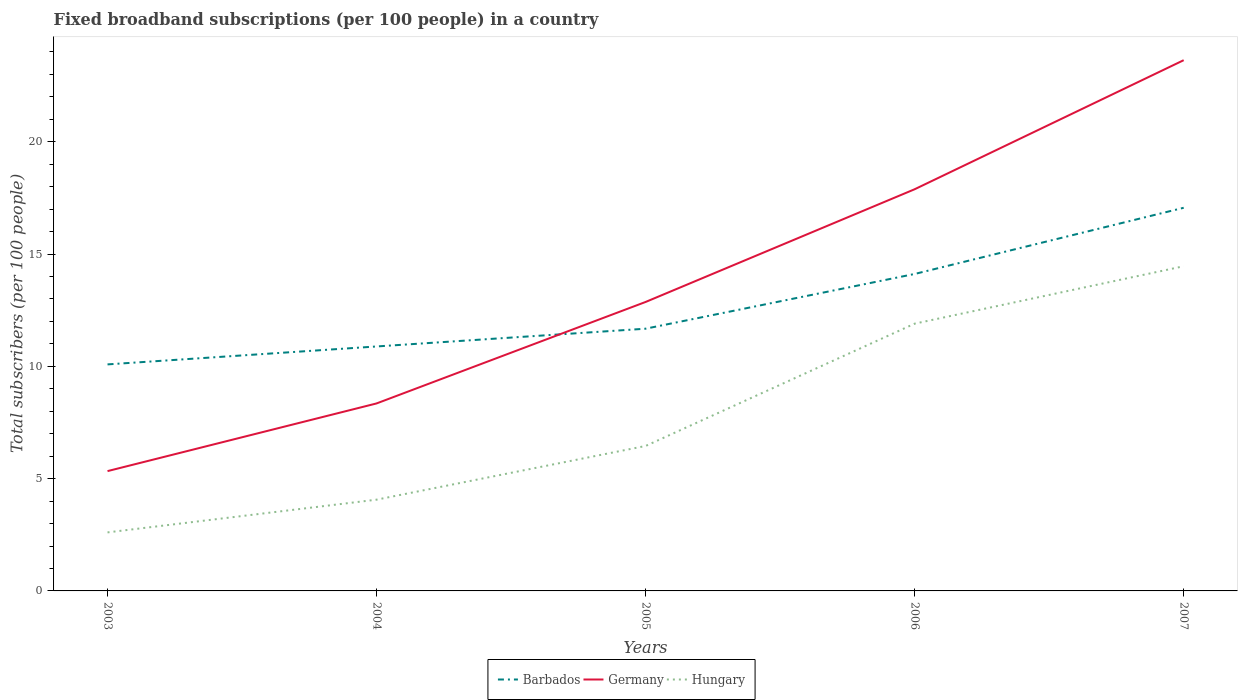How many different coloured lines are there?
Your response must be concise. 3. Is the number of lines equal to the number of legend labels?
Provide a short and direct response. Yes. Across all years, what is the maximum number of broadband subscriptions in Germany?
Provide a succinct answer. 5.33. In which year was the number of broadband subscriptions in Barbados maximum?
Offer a very short reply. 2003. What is the total number of broadband subscriptions in Barbados in the graph?
Give a very brief answer. -0.79. What is the difference between the highest and the second highest number of broadband subscriptions in Barbados?
Provide a short and direct response. 6.97. What is the difference between the highest and the lowest number of broadband subscriptions in Barbados?
Your answer should be very brief. 2. Is the number of broadband subscriptions in Hungary strictly greater than the number of broadband subscriptions in Barbados over the years?
Give a very brief answer. Yes. How many years are there in the graph?
Ensure brevity in your answer.  5. What is the difference between two consecutive major ticks on the Y-axis?
Provide a succinct answer. 5. Are the values on the major ticks of Y-axis written in scientific E-notation?
Give a very brief answer. No. Does the graph contain any zero values?
Give a very brief answer. No. Does the graph contain grids?
Your response must be concise. No. How are the legend labels stacked?
Provide a short and direct response. Horizontal. What is the title of the graph?
Give a very brief answer. Fixed broadband subscriptions (per 100 people) in a country. Does "Mauritius" appear as one of the legend labels in the graph?
Ensure brevity in your answer.  No. What is the label or title of the Y-axis?
Make the answer very short. Total subscribers (per 100 people). What is the Total subscribers (per 100 people) in Barbados in 2003?
Keep it short and to the point. 10.09. What is the Total subscribers (per 100 people) of Germany in 2003?
Provide a succinct answer. 5.33. What is the Total subscribers (per 100 people) in Hungary in 2003?
Provide a short and direct response. 2.61. What is the Total subscribers (per 100 people) of Barbados in 2004?
Make the answer very short. 10.89. What is the Total subscribers (per 100 people) of Germany in 2004?
Your answer should be very brief. 8.35. What is the Total subscribers (per 100 people) in Hungary in 2004?
Your response must be concise. 4.06. What is the Total subscribers (per 100 people) in Barbados in 2005?
Offer a very short reply. 11.68. What is the Total subscribers (per 100 people) in Germany in 2005?
Provide a succinct answer. 12.87. What is the Total subscribers (per 100 people) in Hungary in 2005?
Your answer should be very brief. 6.45. What is the Total subscribers (per 100 people) of Barbados in 2006?
Offer a terse response. 14.11. What is the Total subscribers (per 100 people) in Germany in 2006?
Keep it short and to the point. 17.89. What is the Total subscribers (per 100 people) of Hungary in 2006?
Your answer should be compact. 11.9. What is the Total subscribers (per 100 people) in Barbados in 2007?
Your answer should be very brief. 17.06. What is the Total subscribers (per 100 people) of Germany in 2007?
Your answer should be very brief. 23.63. What is the Total subscribers (per 100 people) of Hungary in 2007?
Your response must be concise. 14.46. Across all years, what is the maximum Total subscribers (per 100 people) in Barbados?
Provide a short and direct response. 17.06. Across all years, what is the maximum Total subscribers (per 100 people) in Germany?
Keep it short and to the point. 23.63. Across all years, what is the maximum Total subscribers (per 100 people) of Hungary?
Your answer should be compact. 14.46. Across all years, what is the minimum Total subscribers (per 100 people) of Barbados?
Your answer should be compact. 10.09. Across all years, what is the minimum Total subscribers (per 100 people) of Germany?
Provide a short and direct response. 5.33. Across all years, what is the minimum Total subscribers (per 100 people) in Hungary?
Make the answer very short. 2.61. What is the total Total subscribers (per 100 people) of Barbados in the graph?
Make the answer very short. 63.82. What is the total Total subscribers (per 100 people) of Germany in the graph?
Offer a very short reply. 68.07. What is the total Total subscribers (per 100 people) of Hungary in the graph?
Make the answer very short. 39.48. What is the difference between the Total subscribers (per 100 people) in Barbados in 2003 and that in 2004?
Make the answer very short. -0.8. What is the difference between the Total subscribers (per 100 people) of Germany in 2003 and that in 2004?
Ensure brevity in your answer.  -3.01. What is the difference between the Total subscribers (per 100 people) of Hungary in 2003 and that in 2004?
Give a very brief answer. -1.46. What is the difference between the Total subscribers (per 100 people) of Barbados in 2003 and that in 2005?
Give a very brief answer. -1.59. What is the difference between the Total subscribers (per 100 people) in Germany in 2003 and that in 2005?
Provide a short and direct response. -7.53. What is the difference between the Total subscribers (per 100 people) in Hungary in 2003 and that in 2005?
Your answer should be very brief. -3.85. What is the difference between the Total subscribers (per 100 people) of Barbados in 2003 and that in 2006?
Keep it short and to the point. -4.03. What is the difference between the Total subscribers (per 100 people) in Germany in 2003 and that in 2006?
Ensure brevity in your answer.  -12.55. What is the difference between the Total subscribers (per 100 people) of Hungary in 2003 and that in 2006?
Provide a short and direct response. -9.29. What is the difference between the Total subscribers (per 100 people) of Barbados in 2003 and that in 2007?
Your answer should be compact. -6.97. What is the difference between the Total subscribers (per 100 people) in Germany in 2003 and that in 2007?
Offer a terse response. -18.3. What is the difference between the Total subscribers (per 100 people) of Hungary in 2003 and that in 2007?
Provide a short and direct response. -11.85. What is the difference between the Total subscribers (per 100 people) in Barbados in 2004 and that in 2005?
Offer a very short reply. -0.79. What is the difference between the Total subscribers (per 100 people) of Germany in 2004 and that in 2005?
Your answer should be very brief. -4.52. What is the difference between the Total subscribers (per 100 people) of Hungary in 2004 and that in 2005?
Provide a succinct answer. -2.39. What is the difference between the Total subscribers (per 100 people) in Barbados in 2004 and that in 2006?
Provide a succinct answer. -3.23. What is the difference between the Total subscribers (per 100 people) in Germany in 2004 and that in 2006?
Your answer should be compact. -9.54. What is the difference between the Total subscribers (per 100 people) of Hungary in 2004 and that in 2006?
Make the answer very short. -7.84. What is the difference between the Total subscribers (per 100 people) in Barbados in 2004 and that in 2007?
Ensure brevity in your answer.  -6.17. What is the difference between the Total subscribers (per 100 people) of Germany in 2004 and that in 2007?
Your response must be concise. -15.28. What is the difference between the Total subscribers (per 100 people) of Hungary in 2004 and that in 2007?
Your answer should be compact. -10.39. What is the difference between the Total subscribers (per 100 people) in Barbados in 2005 and that in 2006?
Make the answer very short. -2.44. What is the difference between the Total subscribers (per 100 people) of Germany in 2005 and that in 2006?
Keep it short and to the point. -5.02. What is the difference between the Total subscribers (per 100 people) of Hungary in 2005 and that in 2006?
Provide a short and direct response. -5.45. What is the difference between the Total subscribers (per 100 people) of Barbados in 2005 and that in 2007?
Provide a succinct answer. -5.38. What is the difference between the Total subscribers (per 100 people) in Germany in 2005 and that in 2007?
Offer a terse response. -10.77. What is the difference between the Total subscribers (per 100 people) of Hungary in 2005 and that in 2007?
Offer a terse response. -8. What is the difference between the Total subscribers (per 100 people) of Barbados in 2006 and that in 2007?
Offer a very short reply. -2.95. What is the difference between the Total subscribers (per 100 people) in Germany in 2006 and that in 2007?
Give a very brief answer. -5.75. What is the difference between the Total subscribers (per 100 people) in Hungary in 2006 and that in 2007?
Provide a short and direct response. -2.56. What is the difference between the Total subscribers (per 100 people) in Barbados in 2003 and the Total subscribers (per 100 people) in Germany in 2004?
Provide a succinct answer. 1.74. What is the difference between the Total subscribers (per 100 people) of Barbados in 2003 and the Total subscribers (per 100 people) of Hungary in 2004?
Provide a succinct answer. 6.02. What is the difference between the Total subscribers (per 100 people) in Germany in 2003 and the Total subscribers (per 100 people) in Hungary in 2004?
Give a very brief answer. 1.27. What is the difference between the Total subscribers (per 100 people) of Barbados in 2003 and the Total subscribers (per 100 people) of Germany in 2005?
Provide a short and direct response. -2.78. What is the difference between the Total subscribers (per 100 people) of Barbados in 2003 and the Total subscribers (per 100 people) of Hungary in 2005?
Make the answer very short. 3.63. What is the difference between the Total subscribers (per 100 people) in Germany in 2003 and the Total subscribers (per 100 people) in Hungary in 2005?
Give a very brief answer. -1.12. What is the difference between the Total subscribers (per 100 people) of Barbados in 2003 and the Total subscribers (per 100 people) of Germany in 2006?
Ensure brevity in your answer.  -7.8. What is the difference between the Total subscribers (per 100 people) of Barbados in 2003 and the Total subscribers (per 100 people) of Hungary in 2006?
Offer a very short reply. -1.81. What is the difference between the Total subscribers (per 100 people) of Germany in 2003 and the Total subscribers (per 100 people) of Hungary in 2006?
Offer a terse response. -6.57. What is the difference between the Total subscribers (per 100 people) in Barbados in 2003 and the Total subscribers (per 100 people) in Germany in 2007?
Offer a terse response. -13.55. What is the difference between the Total subscribers (per 100 people) of Barbados in 2003 and the Total subscribers (per 100 people) of Hungary in 2007?
Ensure brevity in your answer.  -4.37. What is the difference between the Total subscribers (per 100 people) in Germany in 2003 and the Total subscribers (per 100 people) in Hungary in 2007?
Your answer should be compact. -9.12. What is the difference between the Total subscribers (per 100 people) in Barbados in 2004 and the Total subscribers (per 100 people) in Germany in 2005?
Offer a terse response. -1.98. What is the difference between the Total subscribers (per 100 people) of Barbados in 2004 and the Total subscribers (per 100 people) of Hungary in 2005?
Provide a short and direct response. 4.43. What is the difference between the Total subscribers (per 100 people) of Germany in 2004 and the Total subscribers (per 100 people) of Hungary in 2005?
Provide a short and direct response. 1.89. What is the difference between the Total subscribers (per 100 people) in Barbados in 2004 and the Total subscribers (per 100 people) in Germany in 2006?
Provide a short and direct response. -7. What is the difference between the Total subscribers (per 100 people) in Barbados in 2004 and the Total subscribers (per 100 people) in Hungary in 2006?
Your response must be concise. -1.02. What is the difference between the Total subscribers (per 100 people) in Germany in 2004 and the Total subscribers (per 100 people) in Hungary in 2006?
Your answer should be compact. -3.55. What is the difference between the Total subscribers (per 100 people) of Barbados in 2004 and the Total subscribers (per 100 people) of Germany in 2007?
Your answer should be very brief. -12.75. What is the difference between the Total subscribers (per 100 people) of Barbados in 2004 and the Total subscribers (per 100 people) of Hungary in 2007?
Make the answer very short. -3.57. What is the difference between the Total subscribers (per 100 people) in Germany in 2004 and the Total subscribers (per 100 people) in Hungary in 2007?
Provide a short and direct response. -6.11. What is the difference between the Total subscribers (per 100 people) of Barbados in 2005 and the Total subscribers (per 100 people) of Germany in 2006?
Your answer should be very brief. -6.21. What is the difference between the Total subscribers (per 100 people) in Barbados in 2005 and the Total subscribers (per 100 people) in Hungary in 2006?
Give a very brief answer. -0.22. What is the difference between the Total subscribers (per 100 people) of Germany in 2005 and the Total subscribers (per 100 people) of Hungary in 2006?
Offer a terse response. 0.97. What is the difference between the Total subscribers (per 100 people) in Barbados in 2005 and the Total subscribers (per 100 people) in Germany in 2007?
Offer a very short reply. -11.96. What is the difference between the Total subscribers (per 100 people) of Barbados in 2005 and the Total subscribers (per 100 people) of Hungary in 2007?
Offer a terse response. -2.78. What is the difference between the Total subscribers (per 100 people) of Germany in 2005 and the Total subscribers (per 100 people) of Hungary in 2007?
Your answer should be compact. -1.59. What is the difference between the Total subscribers (per 100 people) in Barbados in 2006 and the Total subscribers (per 100 people) in Germany in 2007?
Offer a terse response. -9.52. What is the difference between the Total subscribers (per 100 people) in Barbados in 2006 and the Total subscribers (per 100 people) in Hungary in 2007?
Give a very brief answer. -0.34. What is the difference between the Total subscribers (per 100 people) of Germany in 2006 and the Total subscribers (per 100 people) of Hungary in 2007?
Your response must be concise. 3.43. What is the average Total subscribers (per 100 people) of Barbados per year?
Your response must be concise. 12.76. What is the average Total subscribers (per 100 people) in Germany per year?
Your answer should be very brief. 13.61. What is the average Total subscribers (per 100 people) of Hungary per year?
Ensure brevity in your answer.  7.9. In the year 2003, what is the difference between the Total subscribers (per 100 people) of Barbados and Total subscribers (per 100 people) of Germany?
Give a very brief answer. 4.75. In the year 2003, what is the difference between the Total subscribers (per 100 people) in Barbados and Total subscribers (per 100 people) in Hungary?
Provide a short and direct response. 7.48. In the year 2003, what is the difference between the Total subscribers (per 100 people) of Germany and Total subscribers (per 100 people) of Hungary?
Offer a terse response. 2.73. In the year 2004, what is the difference between the Total subscribers (per 100 people) of Barbados and Total subscribers (per 100 people) of Germany?
Offer a terse response. 2.54. In the year 2004, what is the difference between the Total subscribers (per 100 people) of Barbados and Total subscribers (per 100 people) of Hungary?
Offer a very short reply. 6.82. In the year 2004, what is the difference between the Total subscribers (per 100 people) in Germany and Total subscribers (per 100 people) in Hungary?
Ensure brevity in your answer.  4.29. In the year 2005, what is the difference between the Total subscribers (per 100 people) in Barbados and Total subscribers (per 100 people) in Germany?
Offer a terse response. -1.19. In the year 2005, what is the difference between the Total subscribers (per 100 people) of Barbados and Total subscribers (per 100 people) of Hungary?
Your response must be concise. 5.22. In the year 2005, what is the difference between the Total subscribers (per 100 people) in Germany and Total subscribers (per 100 people) in Hungary?
Provide a short and direct response. 6.41. In the year 2006, what is the difference between the Total subscribers (per 100 people) in Barbados and Total subscribers (per 100 people) in Germany?
Your answer should be very brief. -3.77. In the year 2006, what is the difference between the Total subscribers (per 100 people) in Barbados and Total subscribers (per 100 people) in Hungary?
Keep it short and to the point. 2.21. In the year 2006, what is the difference between the Total subscribers (per 100 people) of Germany and Total subscribers (per 100 people) of Hungary?
Your answer should be compact. 5.99. In the year 2007, what is the difference between the Total subscribers (per 100 people) of Barbados and Total subscribers (per 100 people) of Germany?
Provide a short and direct response. -6.57. In the year 2007, what is the difference between the Total subscribers (per 100 people) of Barbados and Total subscribers (per 100 people) of Hungary?
Keep it short and to the point. 2.6. In the year 2007, what is the difference between the Total subscribers (per 100 people) of Germany and Total subscribers (per 100 people) of Hungary?
Keep it short and to the point. 9.17. What is the ratio of the Total subscribers (per 100 people) in Barbados in 2003 to that in 2004?
Make the answer very short. 0.93. What is the ratio of the Total subscribers (per 100 people) of Germany in 2003 to that in 2004?
Offer a terse response. 0.64. What is the ratio of the Total subscribers (per 100 people) of Hungary in 2003 to that in 2004?
Your response must be concise. 0.64. What is the ratio of the Total subscribers (per 100 people) in Barbados in 2003 to that in 2005?
Your answer should be very brief. 0.86. What is the ratio of the Total subscribers (per 100 people) in Germany in 2003 to that in 2005?
Give a very brief answer. 0.41. What is the ratio of the Total subscribers (per 100 people) of Hungary in 2003 to that in 2005?
Ensure brevity in your answer.  0.4. What is the ratio of the Total subscribers (per 100 people) of Barbados in 2003 to that in 2006?
Keep it short and to the point. 0.71. What is the ratio of the Total subscribers (per 100 people) in Germany in 2003 to that in 2006?
Your answer should be very brief. 0.3. What is the ratio of the Total subscribers (per 100 people) of Hungary in 2003 to that in 2006?
Your answer should be very brief. 0.22. What is the ratio of the Total subscribers (per 100 people) in Barbados in 2003 to that in 2007?
Keep it short and to the point. 0.59. What is the ratio of the Total subscribers (per 100 people) of Germany in 2003 to that in 2007?
Your answer should be compact. 0.23. What is the ratio of the Total subscribers (per 100 people) of Hungary in 2003 to that in 2007?
Provide a short and direct response. 0.18. What is the ratio of the Total subscribers (per 100 people) in Barbados in 2004 to that in 2005?
Keep it short and to the point. 0.93. What is the ratio of the Total subscribers (per 100 people) of Germany in 2004 to that in 2005?
Provide a short and direct response. 0.65. What is the ratio of the Total subscribers (per 100 people) in Hungary in 2004 to that in 2005?
Your response must be concise. 0.63. What is the ratio of the Total subscribers (per 100 people) in Barbados in 2004 to that in 2006?
Offer a terse response. 0.77. What is the ratio of the Total subscribers (per 100 people) of Germany in 2004 to that in 2006?
Make the answer very short. 0.47. What is the ratio of the Total subscribers (per 100 people) of Hungary in 2004 to that in 2006?
Ensure brevity in your answer.  0.34. What is the ratio of the Total subscribers (per 100 people) in Barbados in 2004 to that in 2007?
Your answer should be very brief. 0.64. What is the ratio of the Total subscribers (per 100 people) in Germany in 2004 to that in 2007?
Provide a succinct answer. 0.35. What is the ratio of the Total subscribers (per 100 people) of Hungary in 2004 to that in 2007?
Your answer should be very brief. 0.28. What is the ratio of the Total subscribers (per 100 people) of Barbados in 2005 to that in 2006?
Provide a short and direct response. 0.83. What is the ratio of the Total subscribers (per 100 people) of Germany in 2005 to that in 2006?
Keep it short and to the point. 0.72. What is the ratio of the Total subscribers (per 100 people) in Hungary in 2005 to that in 2006?
Offer a terse response. 0.54. What is the ratio of the Total subscribers (per 100 people) of Barbados in 2005 to that in 2007?
Offer a very short reply. 0.68. What is the ratio of the Total subscribers (per 100 people) in Germany in 2005 to that in 2007?
Make the answer very short. 0.54. What is the ratio of the Total subscribers (per 100 people) of Hungary in 2005 to that in 2007?
Offer a terse response. 0.45. What is the ratio of the Total subscribers (per 100 people) in Barbados in 2006 to that in 2007?
Your response must be concise. 0.83. What is the ratio of the Total subscribers (per 100 people) in Germany in 2006 to that in 2007?
Provide a short and direct response. 0.76. What is the ratio of the Total subscribers (per 100 people) in Hungary in 2006 to that in 2007?
Ensure brevity in your answer.  0.82. What is the difference between the highest and the second highest Total subscribers (per 100 people) of Barbados?
Your answer should be compact. 2.95. What is the difference between the highest and the second highest Total subscribers (per 100 people) of Germany?
Give a very brief answer. 5.75. What is the difference between the highest and the second highest Total subscribers (per 100 people) in Hungary?
Keep it short and to the point. 2.56. What is the difference between the highest and the lowest Total subscribers (per 100 people) of Barbados?
Your response must be concise. 6.97. What is the difference between the highest and the lowest Total subscribers (per 100 people) in Germany?
Provide a short and direct response. 18.3. What is the difference between the highest and the lowest Total subscribers (per 100 people) in Hungary?
Your answer should be compact. 11.85. 